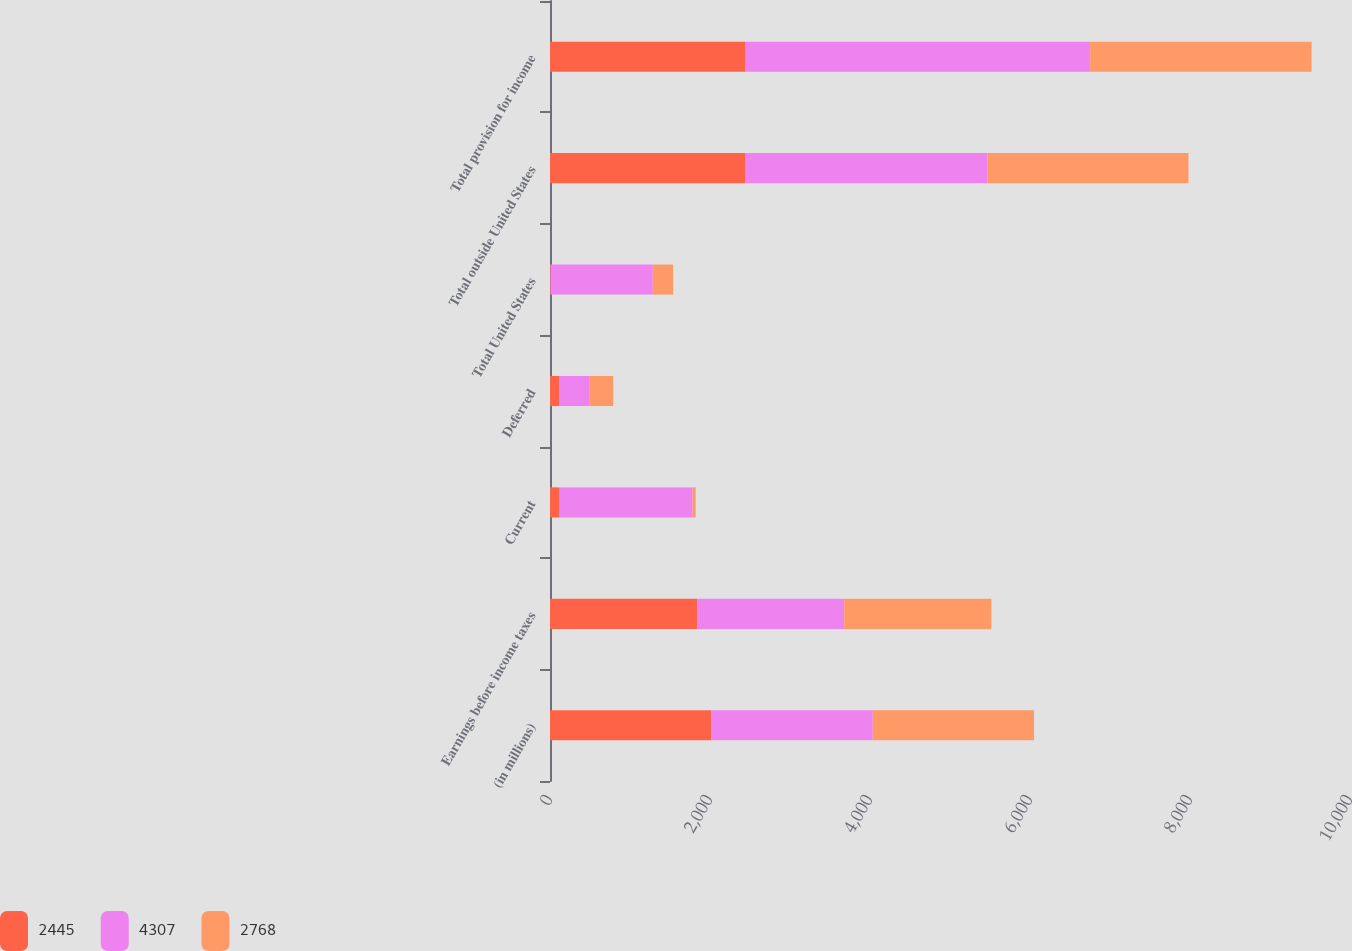Convert chart to OTSL. <chart><loc_0><loc_0><loc_500><loc_500><stacked_bar_chart><ecel><fcel>(in millions)<fcel>Earnings before income taxes<fcel>Current<fcel>Deferred<fcel>Total United States<fcel>Total outside United States<fcel>Total provision for income<nl><fcel>2445<fcel>2018<fcel>1839<fcel>120<fcel>113<fcel>7<fcel>2438<fcel>2445<nl><fcel>4307<fcel>2017<fcel>1839<fcel>1662<fcel>384<fcel>1278<fcel>3029<fcel>4307<nl><fcel>2768<fcel>2016<fcel>1839<fcel>39<fcel>293<fcel>254<fcel>2514<fcel>2768<nl></chart> 